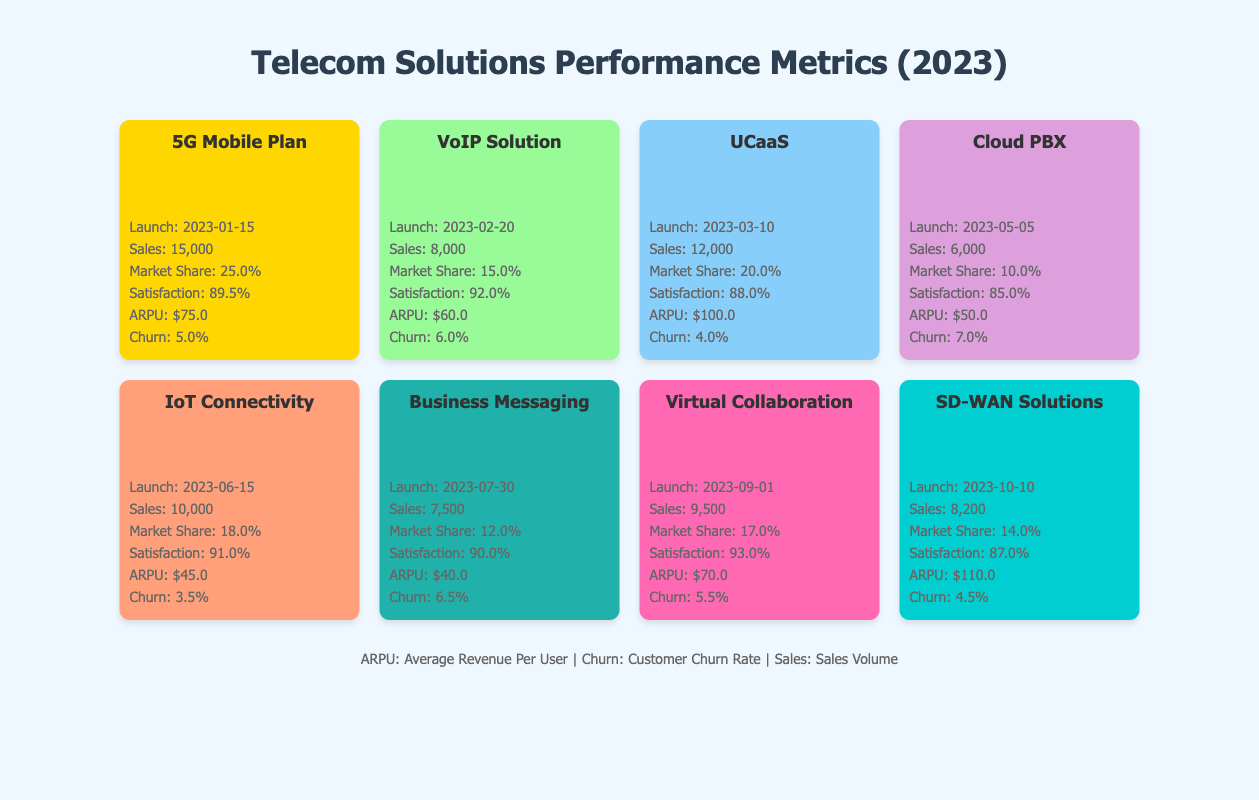What is the sales volume of the 5G Mobile Plan? The sales volume for the 5G Mobile Plan is listed directly in the table under the "Sales" section. It shows 15,000 units sold.
Answer: 15,000 What is the market share of the VoIP Solution? The market share for the VoIP Solution can be found in the table next to the "Market Share" label. It indicates a market share of 15.0%.
Answer: 15.0% Which communication solution has the highest customer satisfaction? To determine the highest customer satisfaction, we look across the "Satisfaction" values for all solutions. The highest value is 93.0% for the Virtual Collaboration Tools.
Answer: Virtual Collaboration Tools What is the average revenue per user (ARPU) for the IoT Connectivity Solutions? The ARPU for IoT Connectivity Solutions is found in the table next to the "ARPU" label, which shows $45.0.
Answer: $45.0 Which solution had the lowest churn rate? We check the "Churn" values for all solutions. The solution with the lowest churn rate is the IoT Connectivity Solutions with a churn rate of 3.5%.
Answer: IoT Connectivity Solutions What is the total sales volume for all solutions launched by mid-2023 (up to and including IoT Connectivity Solutions)? We add the sales volumes of the 5G Mobile Plan (15,000), VoIP Solution (8,000), UCaaS (12,000), Cloud PBX (6,000), and IoT Connectivity Solutions (10,000). So the total is 15,000 + 8,000 + 12,000 + 6,000 + 10,000 = 51,000.
Answer: 51,000 Is the average revenue per user for SD-WAN Solutions greater than the average revenue per user for VoIP Solution? The ARPU for SD-WAN Solutions is $110.0, and for VoIP Solution, it is $60.0. Since $110.0 is greater than $60.0, the statement is true.
Answer: Yes What percentage of the market share does the Cloud PBX hold? The market share listed under the "Market Share" label for Cloud PBX is 10.0%. This value can be directly referenced from the table.
Answer: 10.0% Which two solutions combined have a market share greater than 35%? We look for solutions whose market shares add up to more than 35%. The 5G Mobile Plan (25.0%) and the Unified Communication as a Service (20.0%) combined give us 25.0% + 20.0% = 45.0%, which is indeed greater than 35%.
Answer: Yes, 5G Mobile Plan and UCaaS 